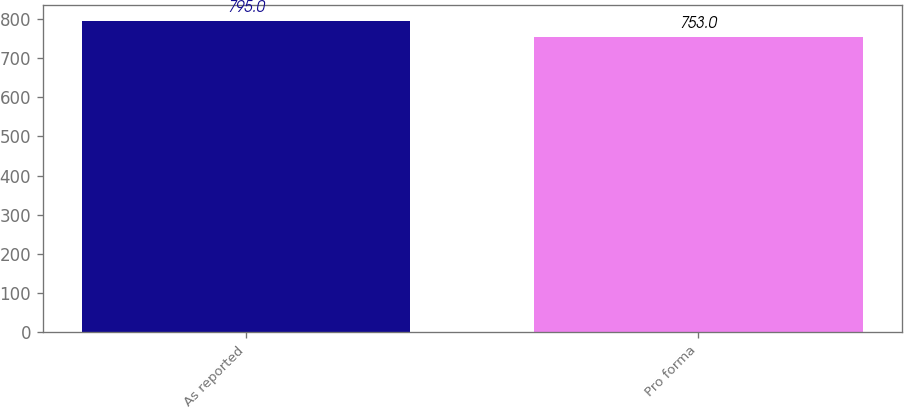Convert chart. <chart><loc_0><loc_0><loc_500><loc_500><bar_chart><fcel>As reported<fcel>Pro forma<nl><fcel>795<fcel>753<nl></chart> 